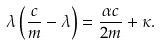<formula> <loc_0><loc_0><loc_500><loc_500>\lambda \left ( \frac { c } { m } - \lambda \right ) = \frac { \alpha c } { 2 m } + \kappa .</formula> 